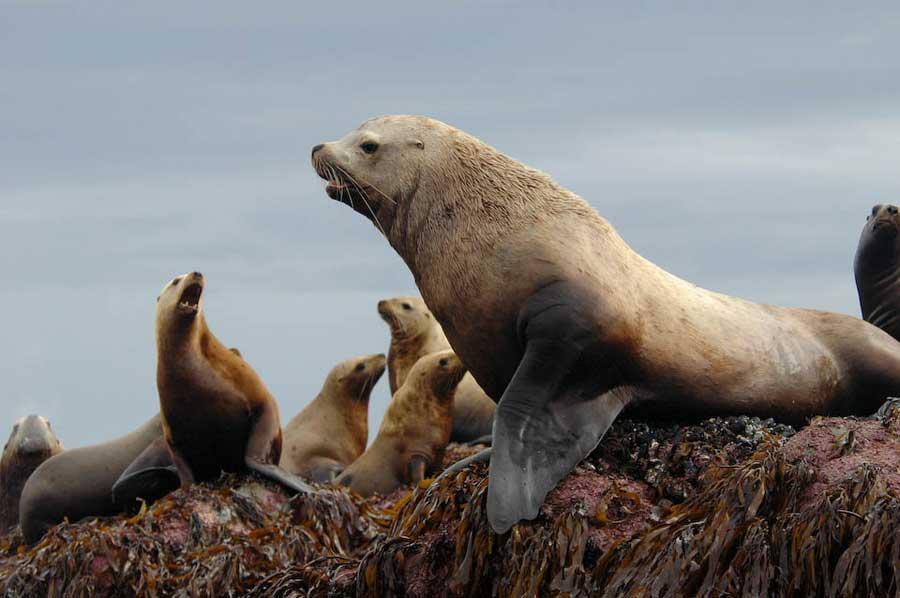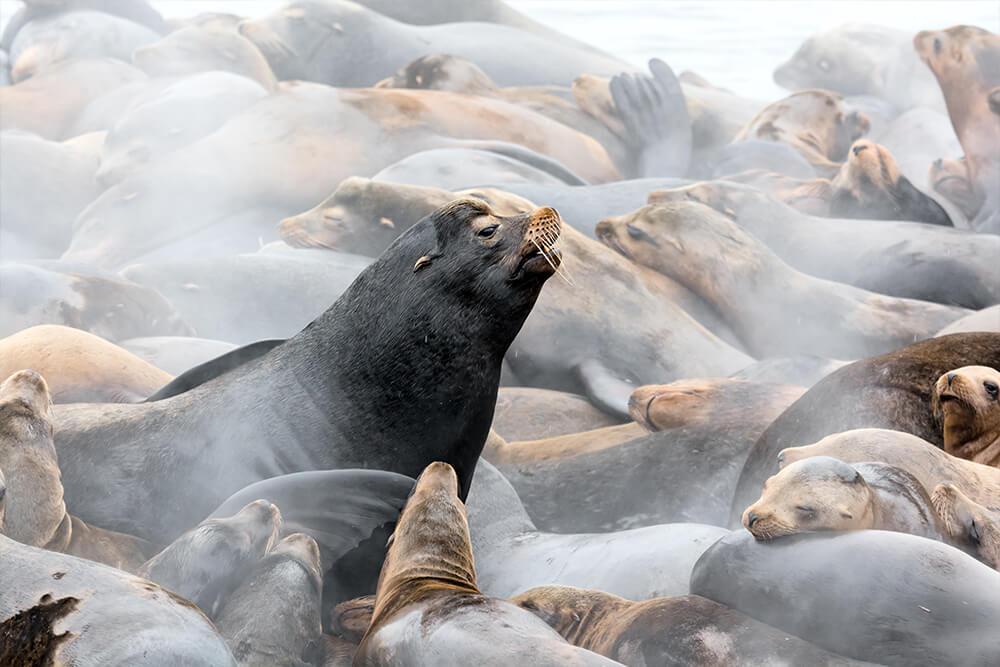The first image is the image on the left, the second image is the image on the right. Given the left and right images, does the statement "One of the images features only two seals." hold true? Answer yes or no. No. The first image is the image on the left, the second image is the image on the right. Considering the images on both sides, is "Each image includes no more than two larger seals with raised head and shoulders surrounded by smaller seals." valid? Answer yes or no. Yes. 